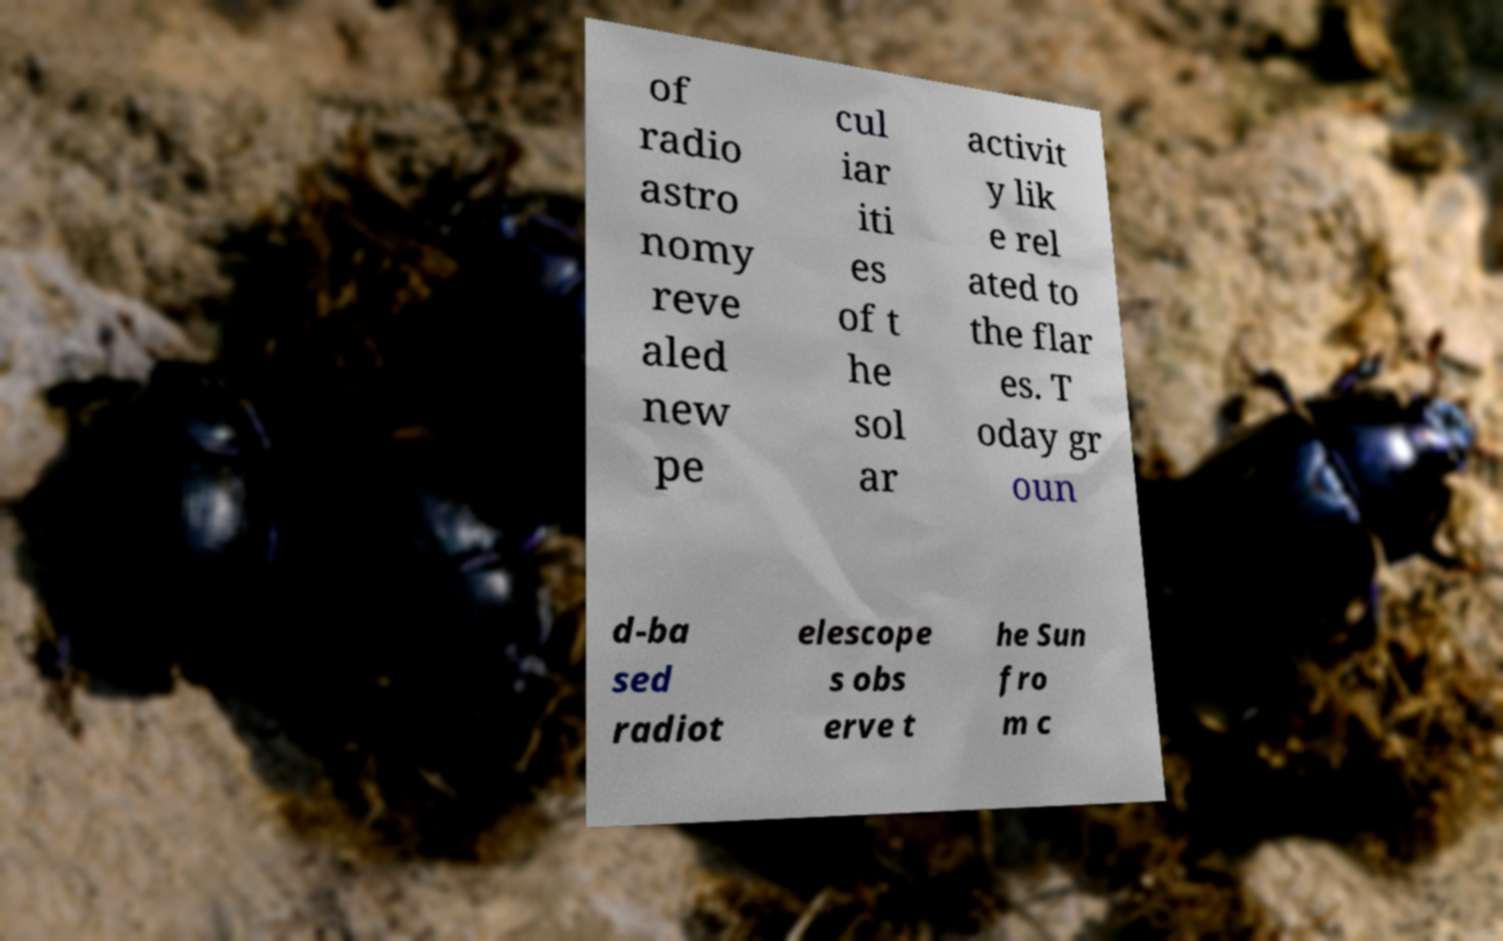There's text embedded in this image that I need extracted. Can you transcribe it verbatim? of radio astro nomy reve aled new pe cul iar iti es of t he sol ar activit y lik e rel ated to the flar es. T oday gr oun d-ba sed radiot elescope s obs erve t he Sun fro m c 